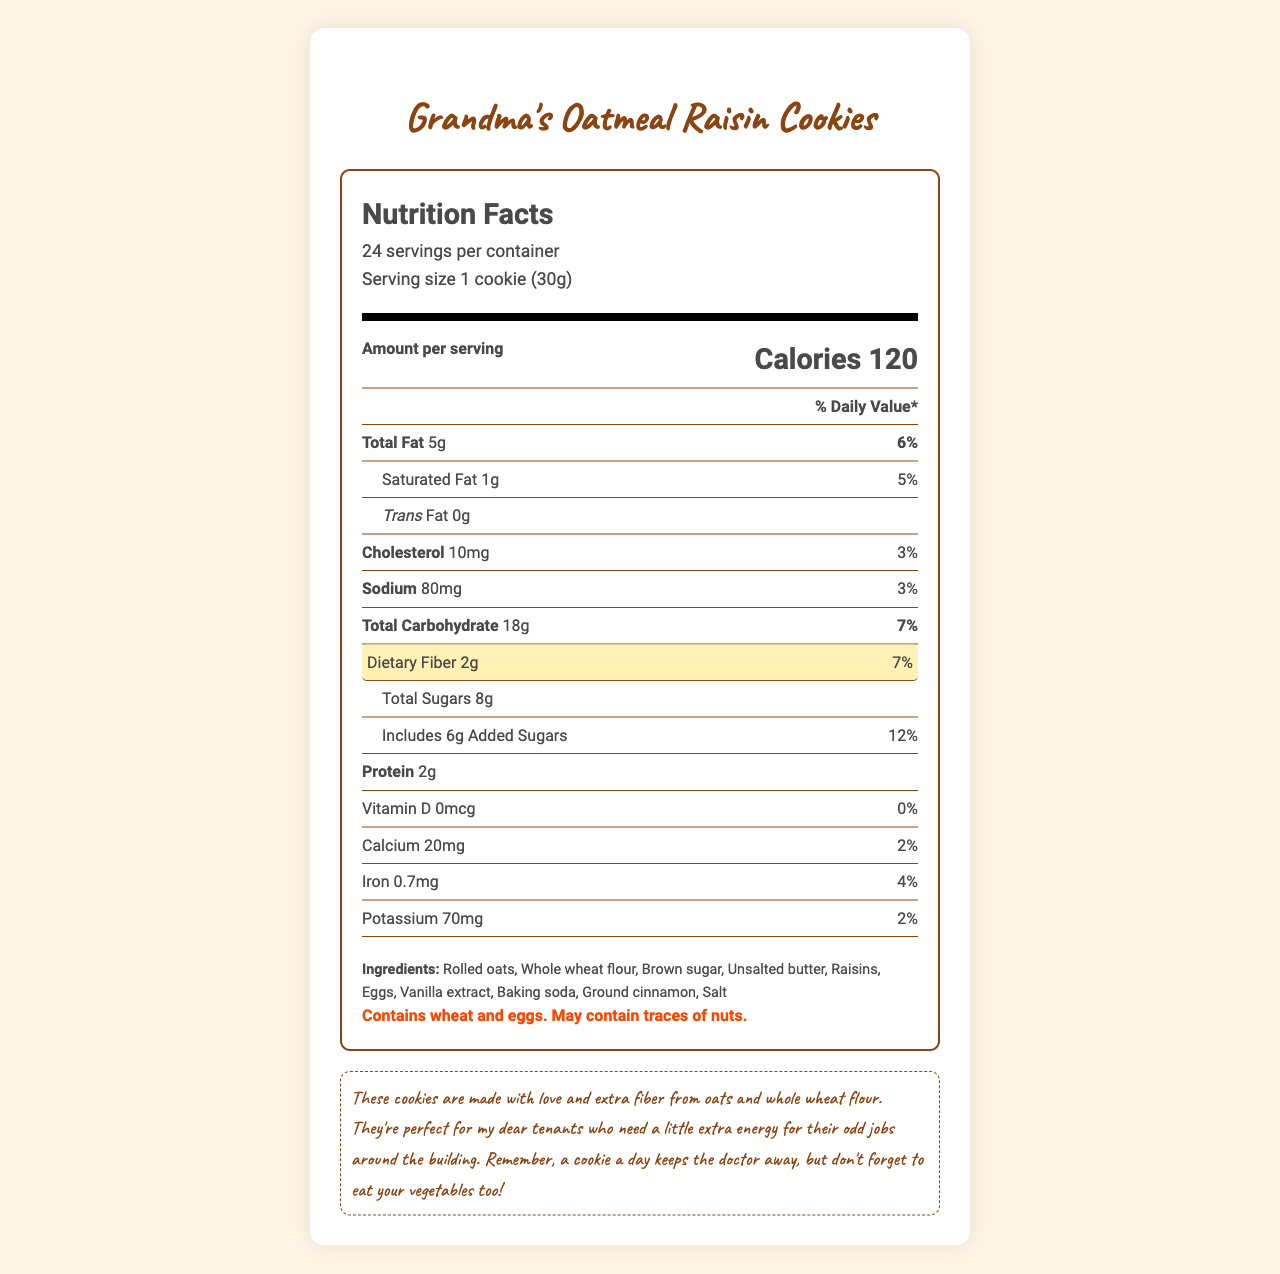what is the serving size? The serving size is mentioned right at the top of the document under the "Nutrition Facts" header. It states "Serving size 1 cookie (30g)".
Answer: 1 cookie (30g) how many servings are in the container? The number of servings per container is indicated next to the serving size at the top of the document. It states "24 servings per container".
Answer: 24 how much dietary fiber is in one serving of the cookies? The dietary fiber content per serving can be found in the highlighted section under the "Dietary Fiber" label. It states "Dietary Fiber 2g".
Answer: 2g what percentage of the daily value for dietary fiber does one serving provide? The document specifies the dietary fiber percentage daily value next to the dietary fiber amount. It states "7%".
Answer: 7% how many calories are there in one cookie? The calorie content per serving is displayed prominently in the document under the "Amount per serving" section. It states "Calories 120".
Answer: 120 how much sugar is in one serving of the cookies? The total sugars content per serving is listed under the "Total Sugars" label. It states "Total Sugars 8g".
Answer: 8g what is the total fat content in one serving? The total fat content per serving is provided under the "Total Fat" label. It states "Total Fat 5g".
Answer: 5g includes how much added sugar? A. 4g B. 6g C. 8g D. 10g The document specifies the amount of added sugars under the "Includes" label. It states "Includes 6g Added Sugars".
Answer: B the cookies contain which of the following allergens? A. Milk B. Wheat C. Soy D. Fish The allergen warning at the bottom of the document indicates which allergens are present. It states "Contains wheat and eggs. May contain traces of nuts."
Answer: B on a per-cookie basis, are there any trans fats? The trans fats content per serving is stated as "Trans Fat 0g", which means there are no trans fats.
Answer: No summarize the key nutrition highlights of Grandma's Oatmeal Raisin Cookies. This summary covers the major nutrition facts and some ingredient information, focusing on the most important nutrient values and percentages.
Answer: The cookies provide a serving size of 1 cookie (30g) with 24 servings per container. Each cookie contains 120 calories, 5g of total fat (6% DV), 1g of saturated fat (5% DV), no trans fat, 10mg of cholesterol (3% DV), 80mg of sodium (3% DV), 18g of total carbohydrates (7% DV), 2g of dietary fiber (7% DV), 8g of total sugars (including 6g of added sugars [12% DV]), and 2g of protein. The cookies also provide small amounts of calcium (2% DV), iron (4% DV), and potassium (2% DV), and contain no vitamin D. how much cholesterol is in each cookie? The cholesterol content per serving is given under the "Cholesterol" label. It states "Cholesterol 10mg".
Answer: 10mg what is the main ingredient in these cookies? The ingredients list is provided at the bottom of the document and rolled oats is listed first, indicating it is the main ingredient.
Answer: Rolled oats can you determine the total fiber content in the entire batch of cookies? While each cookie contains 2g of fiber, without knowing the total batch weight or similar comprehensive details, one cannot determine the total fiber content for the batch.
Answer: Not enough information how much protein is in one cookie? The protein content per serving can be found under the "Protein" label. It states "Protein 2g".
Answer: 2g 